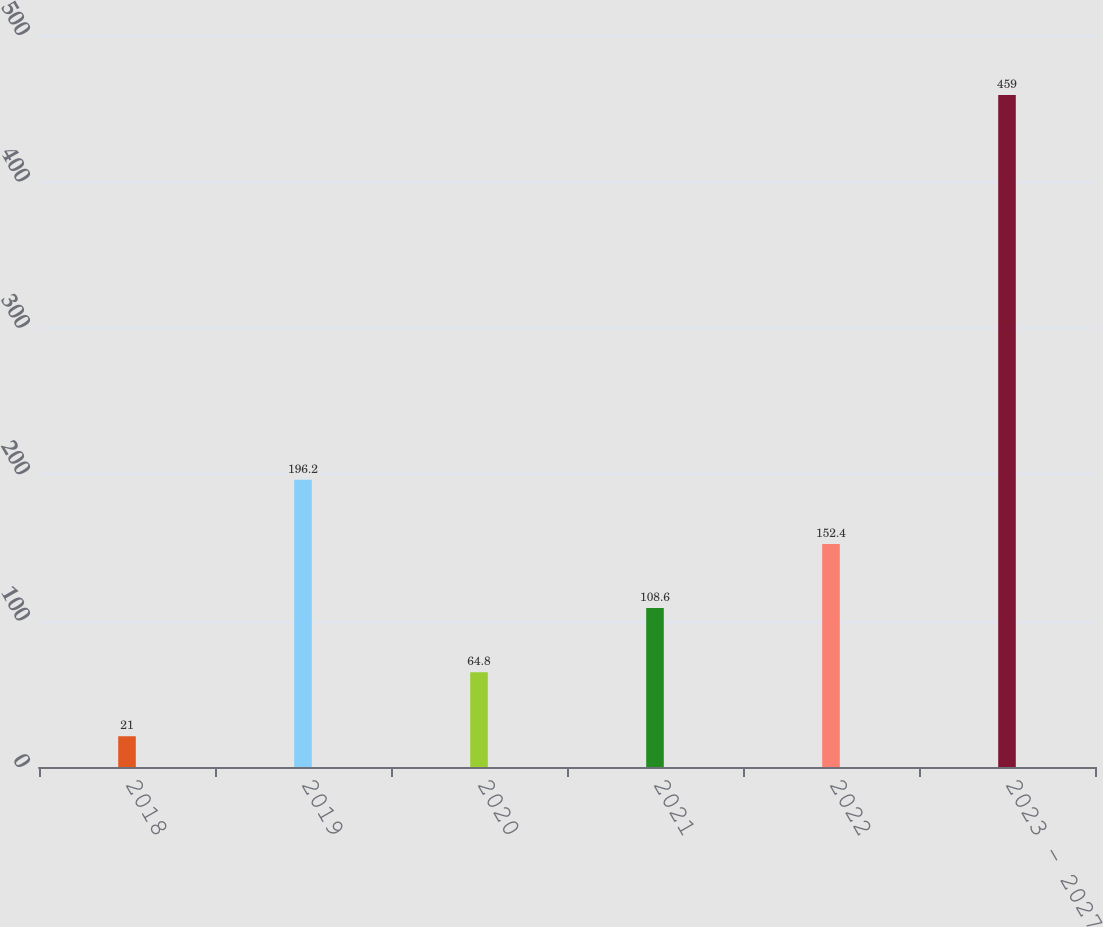<chart> <loc_0><loc_0><loc_500><loc_500><bar_chart><fcel>2018<fcel>2019<fcel>2020<fcel>2021<fcel>2022<fcel>2023 - 2027<nl><fcel>21<fcel>196.2<fcel>64.8<fcel>108.6<fcel>152.4<fcel>459<nl></chart> 